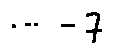<formula> <loc_0><loc_0><loc_500><loc_500>\cdots - 7</formula> 